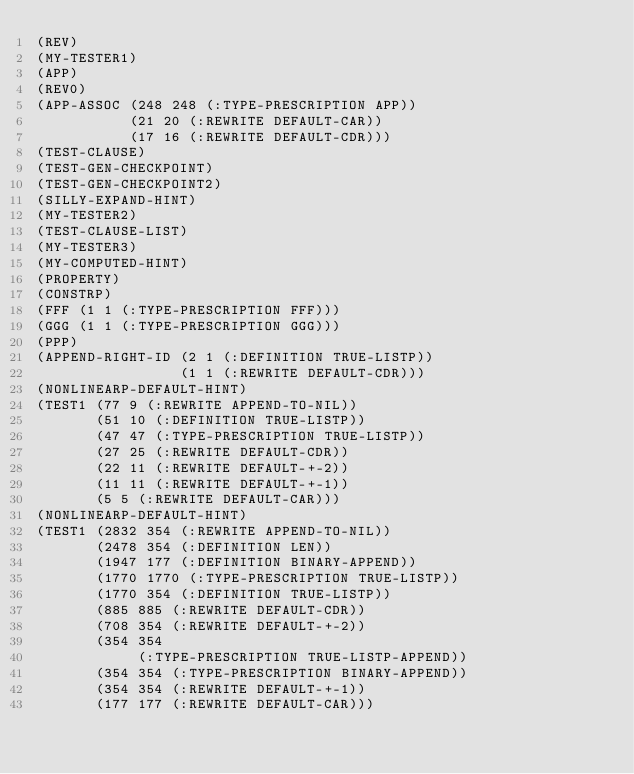Convert code to text. <code><loc_0><loc_0><loc_500><loc_500><_Lisp_>(REV)
(MY-TESTER1)
(APP)
(REV0)
(APP-ASSOC (248 248 (:TYPE-PRESCRIPTION APP))
           (21 20 (:REWRITE DEFAULT-CAR))
           (17 16 (:REWRITE DEFAULT-CDR)))
(TEST-CLAUSE)
(TEST-GEN-CHECKPOINT)
(TEST-GEN-CHECKPOINT2)
(SILLY-EXPAND-HINT)
(MY-TESTER2)
(TEST-CLAUSE-LIST)
(MY-TESTER3)
(MY-COMPUTED-HINT)
(PROPERTY)
(CONSTRP)
(FFF (1 1 (:TYPE-PRESCRIPTION FFF)))
(GGG (1 1 (:TYPE-PRESCRIPTION GGG)))
(PPP)
(APPEND-RIGHT-ID (2 1 (:DEFINITION TRUE-LISTP))
                 (1 1 (:REWRITE DEFAULT-CDR)))
(NONLINEARP-DEFAULT-HINT)
(TEST1 (77 9 (:REWRITE APPEND-TO-NIL))
       (51 10 (:DEFINITION TRUE-LISTP))
       (47 47 (:TYPE-PRESCRIPTION TRUE-LISTP))
       (27 25 (:REWRITE DEFAULT-CDR))
       (22 11 (:REWRITE DEFAULT-+-2))
       (11 11 (:REWRITE DEFAULT-+-1))
       (5 5 (:REWRITE DEFAULT-CAR)))
(NONLINEARP-DEFAULT-HINT)
(TEST1 (2832 354 (:REWRITE APPEND-TO-NIL))
       (2478 354 (:DEFINITION LEN))
       (1947 177 (:DEFINITION BINARY-APPEND))
       (1770 1770 (:TYPE-PRESCRIPTION TRUE-LISTP))
       (1770 354 (:DEFINITION TRUE-LISTP))
       (885 885 (:REWRITE DEFAULT-CDR))
       (708 354 (:REWRITE DEFAULT-+-2))
       (354 354
            (:TYPE-PRESCRIPTION TRUE-LISTP-APPEND))
       (354 354 (:TYPE-PRESCRIPTION BINARY-APPEND))
       (354 354 (:REWRITE DEFAULT-+-1))
       (177 177 (:REWRITE DEFAULT-CAR)))
</code> 